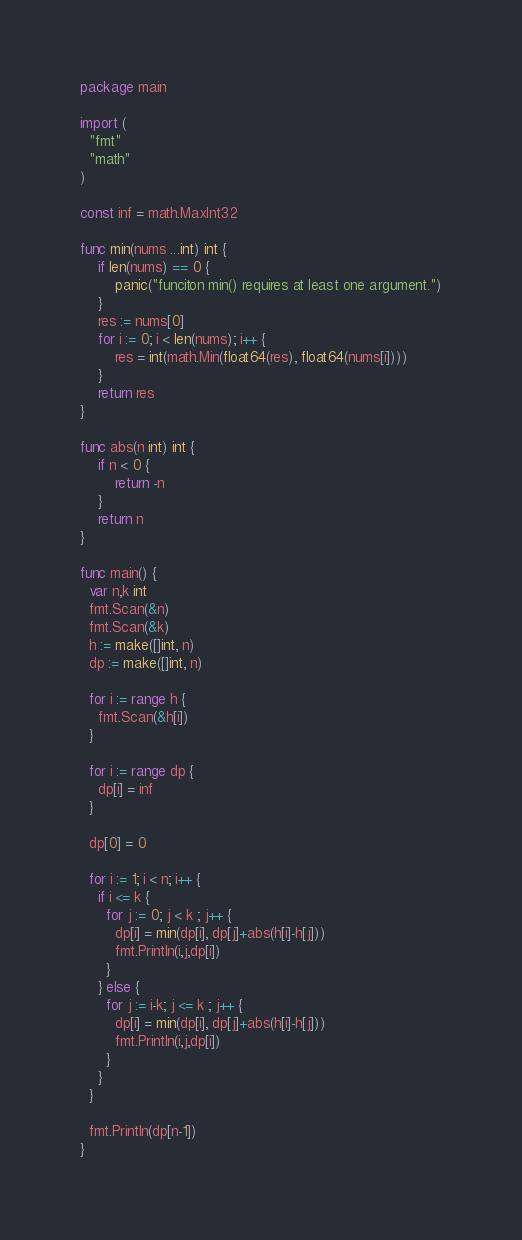Convert code to text. <code><loc_0><loc_0><loc_500><loc_500><_Go_>package main
 
import (
  "fmt"
  "math"
)
 
const inf = math.MaxInt32
 
func min(nums ...int) int {
    if len(nums) == 0 {
        panic("funciton min() requires at least one argument.")
    }
    res := nums[0]
    for i := 0; i < len(nums); i++ {
        res = int(math.Min(float64(res), float64(nums[i])))
    }
    return res
}
 
func abs(n int) int {
	if n < 0 {
		return -n
	}
	return n
}
  
func main() {
  var n,k int
  fmt.Scan(&n)
  fmt.Scan(&k)
  h := make([]int, n)
  dp := make([]int, n)
  
  for i := range h {
    fmt.Scan(&h[i])
  }
 
  for i := range dp {
    dp[i] = inf
  }
 
  dp[0] = 0
  
  for i := 1; i < n; i++ {
    if i <= k {
      for j := 0; j < k ; j++ {
        dp[i] = min(dp[i], dp[j]+abs(h[i]-h[j]))
        fmt.Println(i,j,dp[i])
      } 
    } else {
      for j := i-k; j <= k ; j++ {
        dp[i] = min(dp[i], dp[j]+abs(h[i]-h[j]))
        fmt.Println(i,j,dp[i])
      }
    }
  }
	
  fmt.Println(dp[n-1])
}</code> 